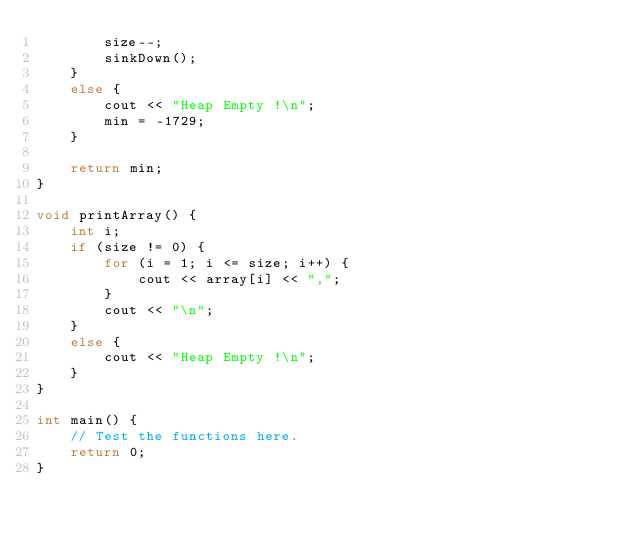<code> <loc_0><loc_0><loc_500><loc_500><_C++_>        size--;
        sinkDown();
    }
    else {
        cout << "Heap Empty !\n";
        min = -1729;
    }

    return min;
}

void printArray() {
    int i;
    if (size != 0) {
        for (i = 1; i <= size; i++) {
            cout << array[i] << ",";
        }
        cout << "\n";
    }
    else {
        cout << "Heap Empty !\n";
    }
}

int main() {
    // Test the functions here.
    return 0;
}
</code> 